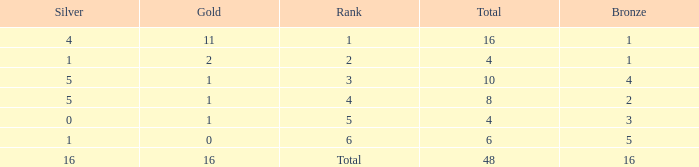How many total gold are less than 4? 0.0. 